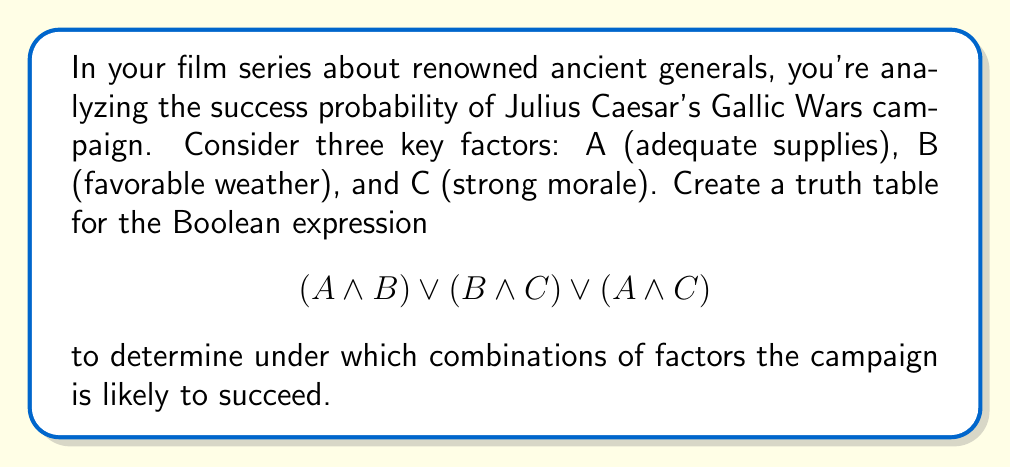Could you help me with this problem? Let's approach this step-by-step:

1) First, we need to create a truth table with all possible combinations of A, B, and C. There are 8 combinations in total (2^3).

2) We'll evaluate the expression $$(A \land B) \lor (B \land C) \lor (A \land C)$$ for each combination.

3) Let's break down the expression into three parts:
   P = $(A \land B)$
   Q = $(B \land C)$
   R = $(A \land C)$

4) Our final expression is $P \lor Q \lor R$

5) Here's the truth table:

   | A | B | C | P | Q | R | Result |
   |---|---|---|---|---|---|--------|
   | 0 | 0 | 0 | 0 | 0 | 0 |   0    |
   | 0 | 0 | 1 | 0 | 0 | 0 |   0    |
   | 0 | 1 | 0 | 0 | 0 | 0 |   0    |
   | 0 | 1 | 1 | 0 | 1 | 0 |   1    |
   | 1 | 0 | 0 | 0 | 0 | 0 |   0    |
   | 1 | 0 | 1 | 0 | 0 | 1 |   1    |
   | 1 | 1 | 0 | 1 | 0 | 0 |   1    |
   | 1 | 1 | 1 | 1 | 1 | 1 |   1    |

6) The campaign is likely to succeed when the result is 1, which occurs in 4 out of 8 scenarios.

7) These successful scenarios are:
   - When B and C are true (adequate supplies not necessary)
   - When A and C are true (favorable weather not necessary)
   - When A and B are true (strong morale not necessary)
   - When all three factors are true
Answer: The campaign succeeds in 4 out of 8 scenarios: $(B \land C)$, $(A \land C)$, $(A \land B)$, or $(A \land B \land C)$. 